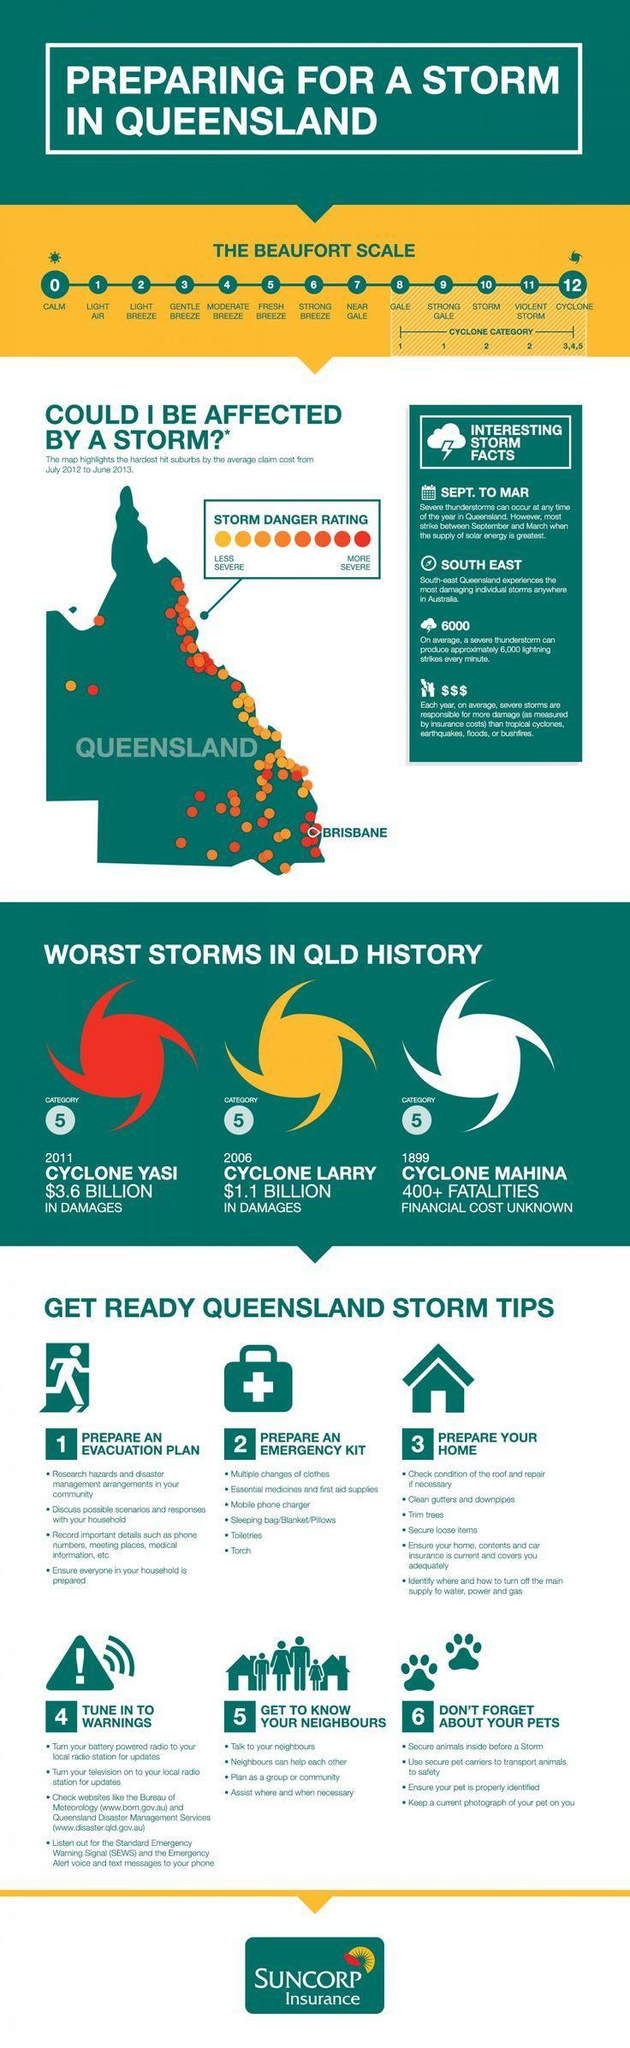which year was cyclone yasi
Answer the question with a short phrase. 2011 what is the colour of the more severe stomr danger rating, yellow or red red what is the second point in get to know your neighbours neighbours can help each other when was cyclone mahina 1899 when was cyclone larry 2006 secure loose items is which storm tip prepare your home what type of wind is considered the beginning of cyclone category gale what storm caused $1.1 billion in damages cyclone larry which storm is the financial cost unknown cyclone mahina 